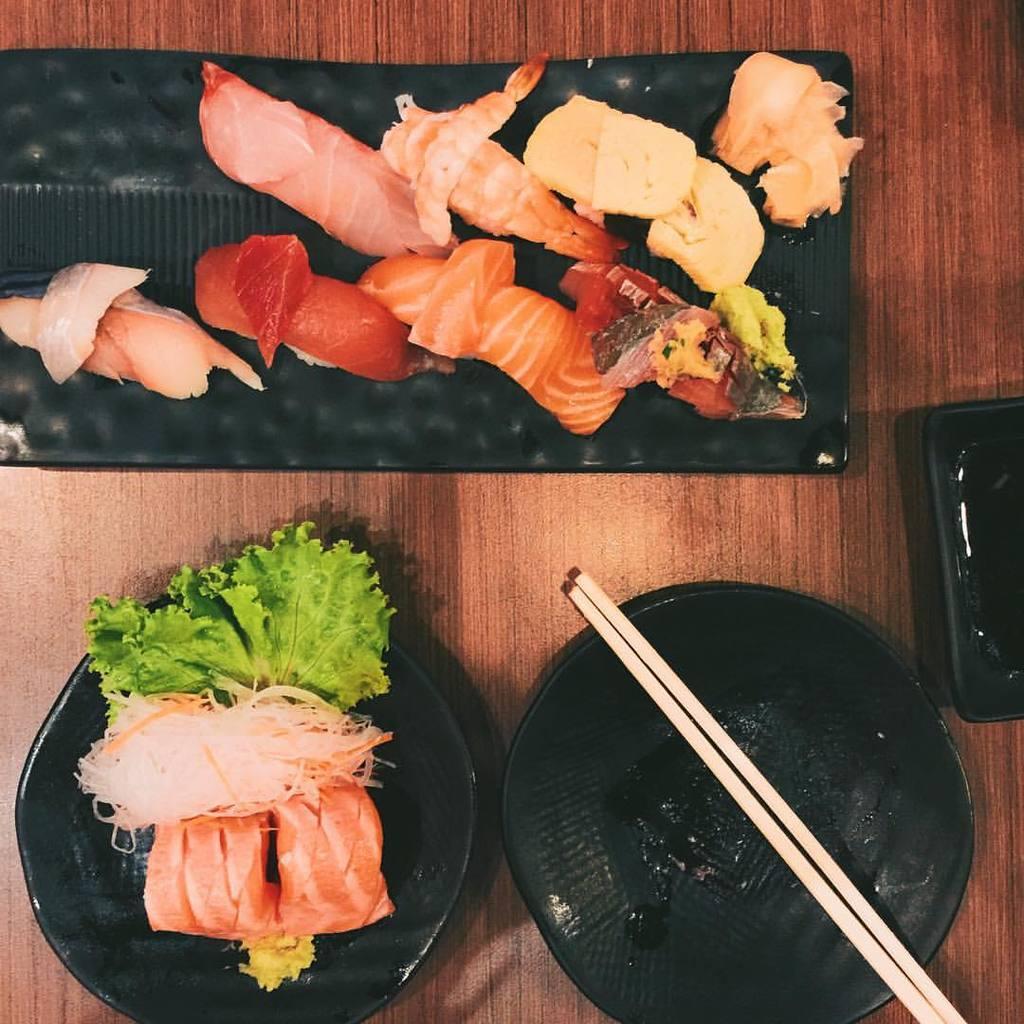In one or two sentences, can you explain what this image depicts? food is placed in the plate on a table. there are chopsticks present. 